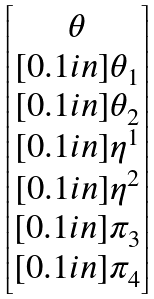<formula> <loc_0><loc_0><loc_500><loc_500>\begin{bmatrix} \theta \\ [ 0 . 1 i n ] \theta _ { 1 } \\ [ 0 . 1 i n ] \theta _ { 2 } \\ [ 0 . 1 i n ] \eta ^ { 1 } \\ [ 0 . 1 i n ] \eta ^ { 2 } \\ [ 0 . 1 i n ] \pi _ { 3 } \\ [ 0 . 1 i n ] \pi _ { 4 } \end{bmatrix}</formula> 